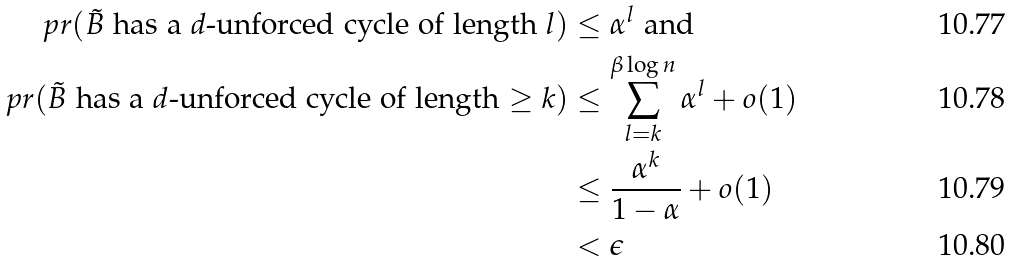Convert formula to latex. <formula><loc_0><loc_0><loc_500><loc_500>\ p r ( \tilde { B } \text { has a $d$-unforced cycle of length $l$} ) & \leq \alpha ^ { l } \text { and} \\ \ p r ( \tilde { B } \text { has a $d$-unforced cycle of length $\geq k$} ) & \leq \sum _ { l = k } ^ { \beta \log n } \alpha ^ { l } + o ( 1 ) \\ & \leq \frac { \alpha ^ { k } } { 1 - \alpha } + o ( 1 ) \\ & < \epsilon</formula> 